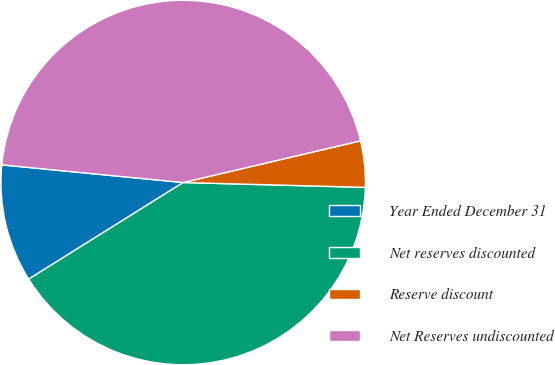Convert chart to OTSL. <chart><loc_0><loc_0><loc_500><loc_500><pie_chart><fcel>Year Ended December 31<fcel>Net reserves discounted<fcel>Reserve discount<fcel>Net Reserves undiscounted<nl><fcel>10.44%<fcel>40.68%<fcel>4.1%<fcel>44.78%<nl></chart> 